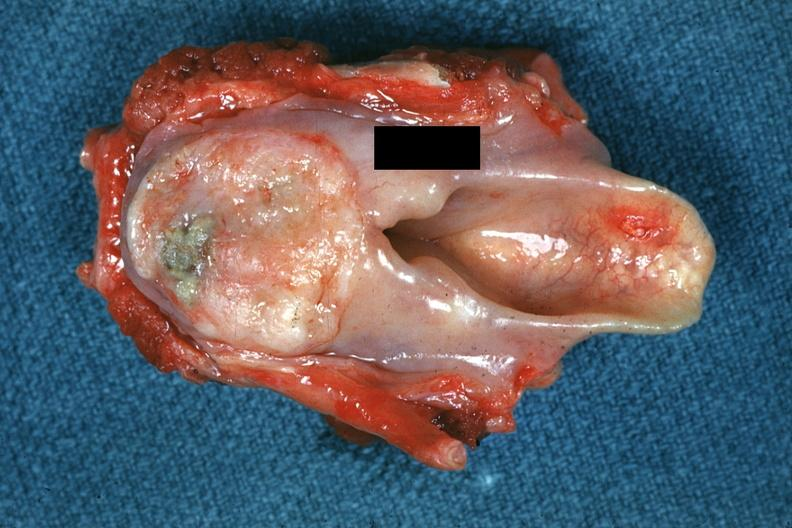where is this?
Answer the question using a single word or phrase. Oral 